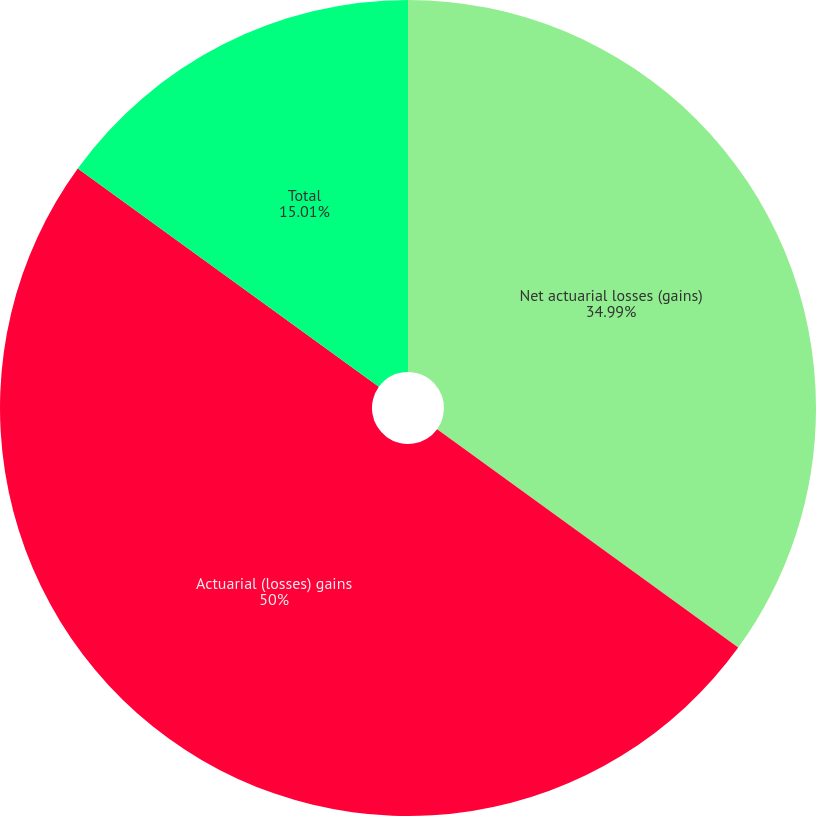Convert chart to OTSL. <chart><loc_0><loc_0><loc_500><loc_500><pie_chart><fcel>Net actuarial losses (gains)<fcel>Actuarial (losses) gains<fcel>Total<nl><fcel>34.99%<fcel>50.0%<fcel>15.01%<nl></chart> 